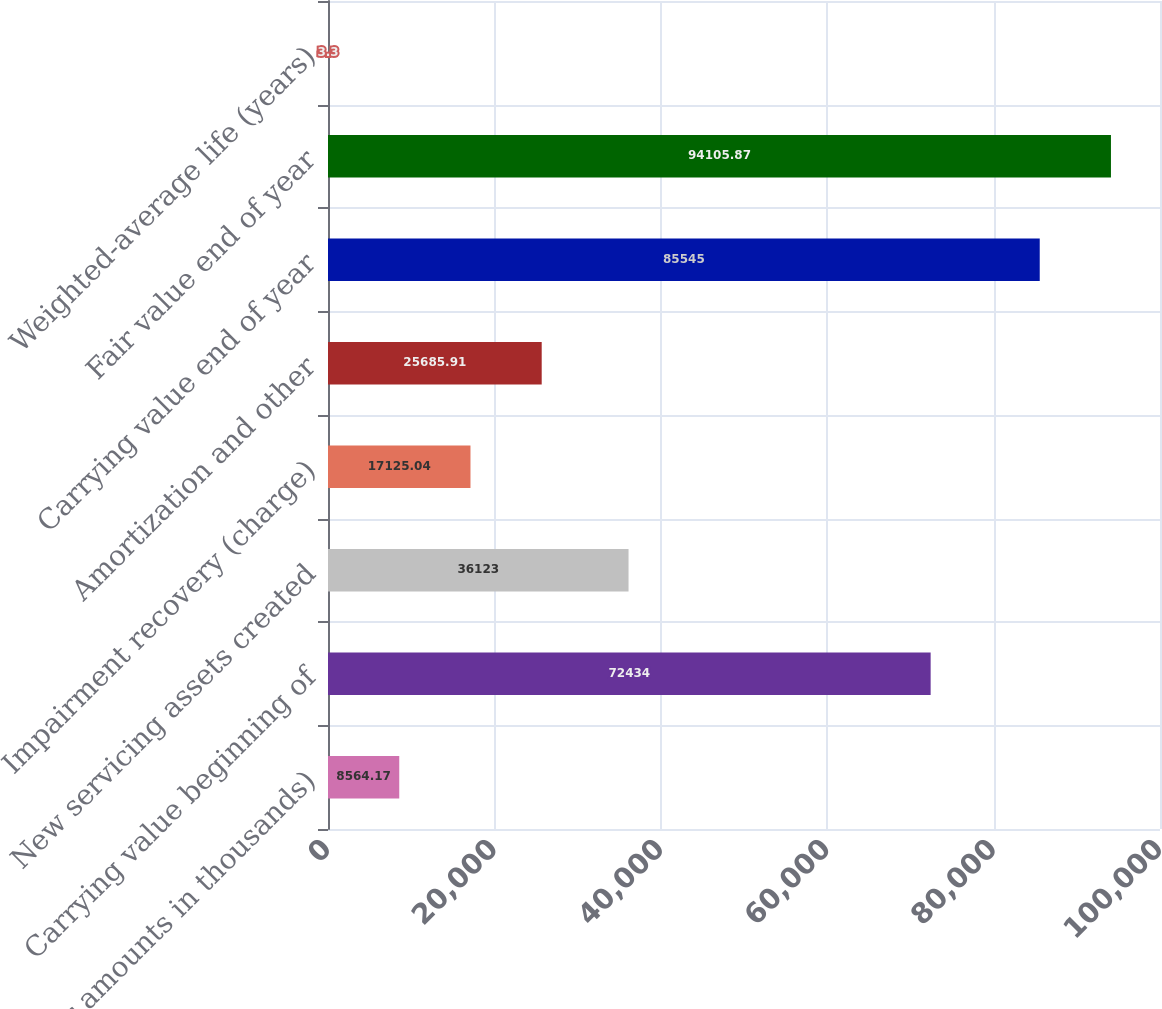Convert chart. <chart><loc_0><loc_0><loc_500><loc_500><bar_chart><fcel>(dollar amounts in thousands)<fcel>Carrying value beginning of<fcel>New servicing assets created<fcel>Impairment recovery (charge)<fcel>Amortization and other<fcel>Carrying value end of year<fcel>Fair value end of year<fcel>Weighted-average life (years)<nl><fcel>8564.17<fcel>72434<fcel>36123<fcel>17125<fcel>25685.9<fcel>85545<fcel>94105.9<fcel>3.3<nl></chart> 